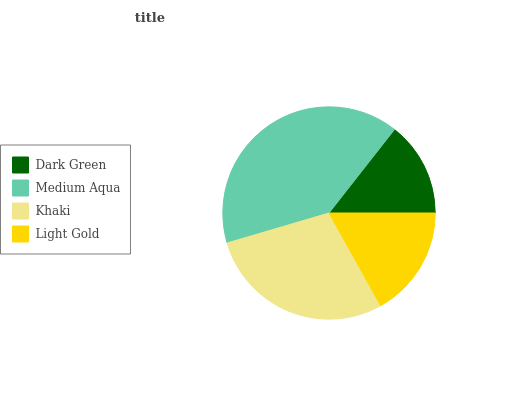Is Dark Green the minimum?
Answer yes or no. Yes. Is Medium Aqua the maximum?
Answer yes or no. Yes. Is Khaki the minimum?
Answer yes or no. No. Is Khaki the maximum?
Answer yes or no. No. Is Medium Aqua greater than Khaki?
Answer yes or no. Yes. Is Khaki less than Medium Aqua?
Answer yes or no. Yes. Is Khaki greater than Medium Aqua?
Answer yes or no. No. Is Medium Aqua less than Khaki?
Answer yes or no. No. Is Khaki the high median?
Answer yes or no. Yes. Is Light Gold the low median?
Answer yes or no. Yes. Is Medium Aqua the high median?
Answer yes or no. No. Is Medium Aqua the low median?
Answer yes or no. No. 